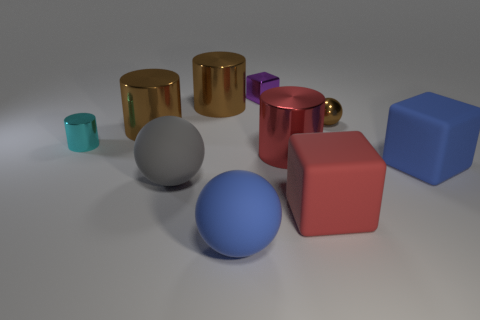Subtract all cylinders. How many objects are left? 6 Add 2 gray matte objects. How many gray matte objects exist? 3 Subtract 0 yellow spheres. How many objects are left? 10 Subtract all small yellow cylinders. Subtract all red objects. How many objects are left? 8 Add 2 large blue matte balls. How many large blue matte balls are left? 3 